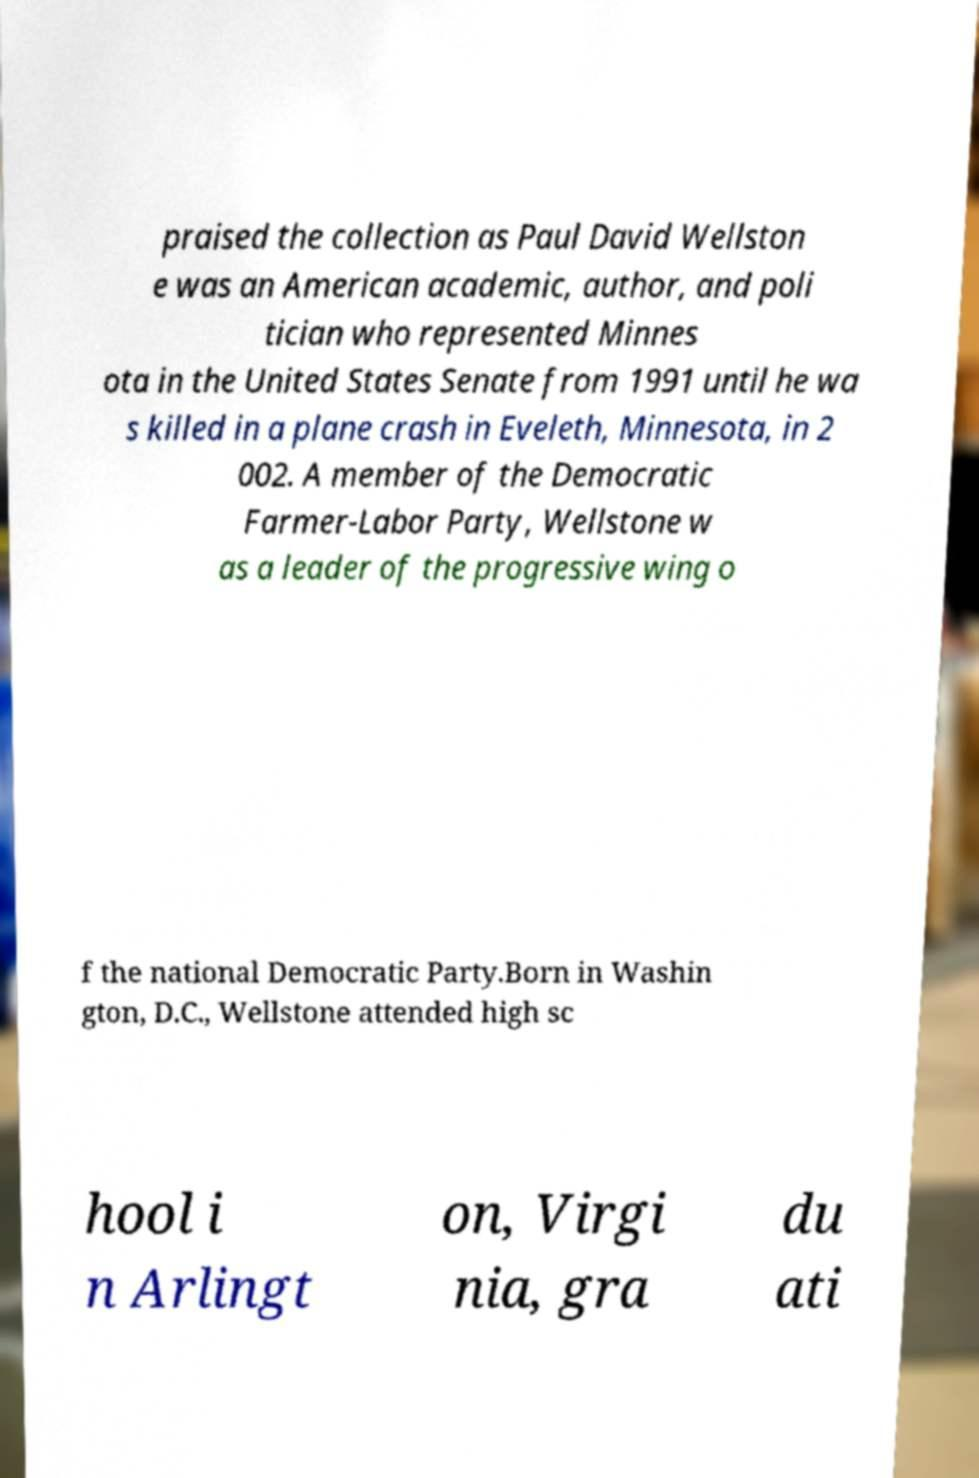Can you accurately transcribe the text from the provided image for me? praised the collection as Paul David Wellston e was an American academic, author, and poli tician who represented Minnes ota in the United States Senate from 1991 until he wa s killed in a plane crash in Eveleth, Minnesota, in 2 002. A member of the Democratic Farmer-Labor Party, Wellstone w as a leader of the progressive wing o f the national Democratic Party.Born in Washin gton, D.C., Wellstone attended high sc hool i n Arlingt on, Virgi nia, gra du ati 